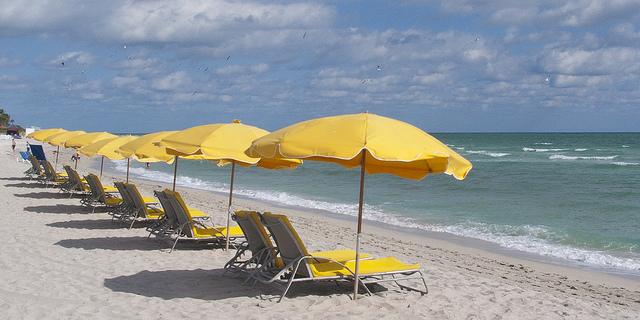How many people are sitting on beach chairs?
Be succinct. 0. Are the umbrellas all yellow?
Quick response, please. Yes. What color are the umbrellas?
Write a very short answer. Yellow. 